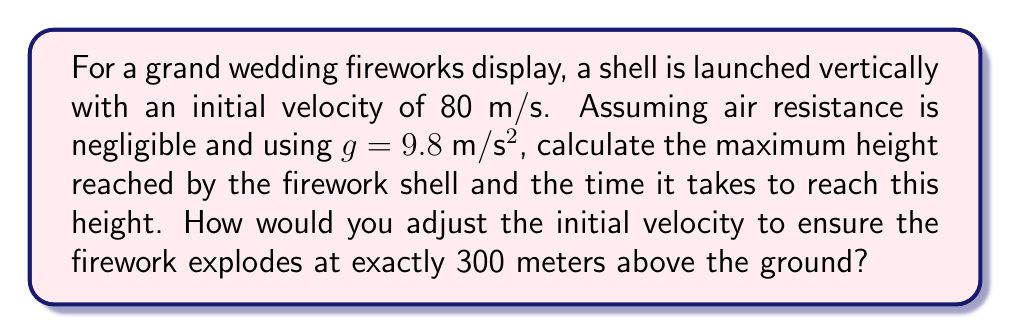Can you solve this math problem? 1. Maximum height calculation:
   We can use the equation: $v^2 = u^2 + 2as$, where
   $v$ = final velocity (0 at maximum height)
   $u$ = initial velocity (80 m/s)
   $a$ = acceleration due to gravity (-9.8 m/s²)
   $s$ = displacement (height reached)

   $$0^2 = 80^2 + 2(-9.8)s$$
   $$s = \frac{80^2}{2(9.8)} = 326.53 \text{ m}$$

2. Time to reach maximum height:
   We can use the equation: $v = u + at$, where
   $v$ = final velocity (0 at maximum height)
   $u$ = initial velocity (80 m/s)
   $a$ = acceleration due to gravity (-9.8 m/s²)
   $t$ = time taken

   $$0 = 80 + (-9.8)t$$
   $$t = \frac{80}{9.8} = 8.16 \text{ s}$$

3. Adjusting initial velocity for 300 m height:
   Using $v^2 = u^2 + 2as$ again, with $s = 300 \text{ m}$:

   $$0^2 = u^2 + 2(-9.8)(300)$$
   $$u^2 = 5880$$
   $$u = \sqrt{5880} = 76.68 \text{ m/s}$$
Answer: Maximum height: 326.53 m, Time: 8.16 s, Adjusted velocity: 76.68 m/s 